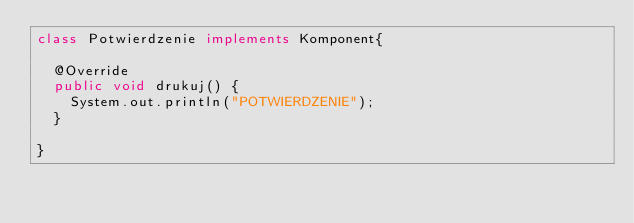Convert code to text. <code><loc_0><loc_0><loc_500><loc_500><_Java_>class Potwierdzenie implements Komponent{

	@Override
	public void drukuj() {
		System.out.println("POTWIERDZENIE");
	}
	
}</code> 